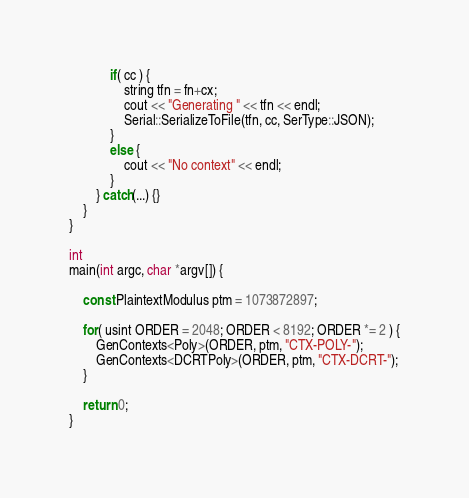Convert code to text. <code><loc_0><loc_0><loc_500><loc_500><_C++_>
			if( cc ) {
				string tfn = fn+cx;
				cout << "Generating " << tfn << endl;
				Serial::SerializeToFile(tfn, cc, SerType::JSON);
			}
			else {
				cout << "No context" << endl;
			}
		} catch(...) {}
	}
}

int
main(int argc, char *argv[]) {

	const PlaintextModulus ptm = 1073872897;

	for( usint ORDER = 2048; ORDER < 8192; ORDER *= 2 ) {
		GenContexts<Poly>(ORDER, ptm, "CTX-POLY-");
		GenContexts<DCRTPoly>(ORDER, ptm, "CTX-DCRT-");
	}

	return 0;
}
</code> 